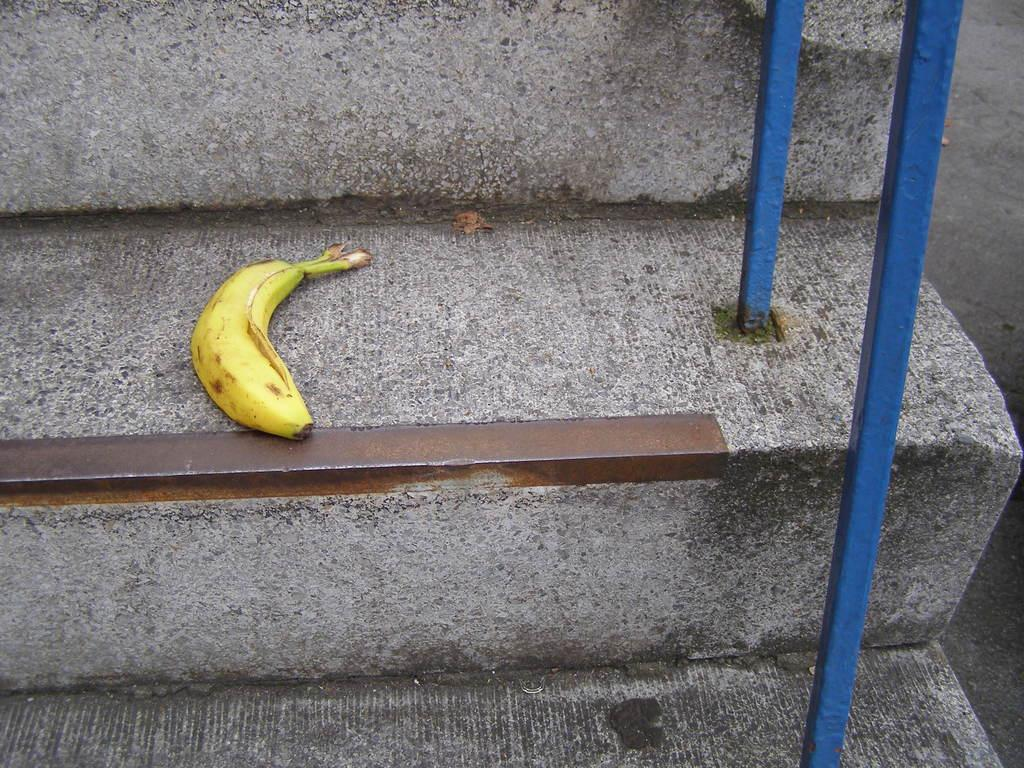What type of structure is present in the image? There are stairs in the image. Is there anything unusual on the stairs? Yes, there is a banana on the stairs. What else can be seen in the image besides the stairs and banana? There is a rod in the image. What is visible at the side of the image? There appears to be a road at the side of the image. Can you tell me how many seeds are in the bike in the image? There is no bike present in the image, and therefore no seeds can be found in a bike. 